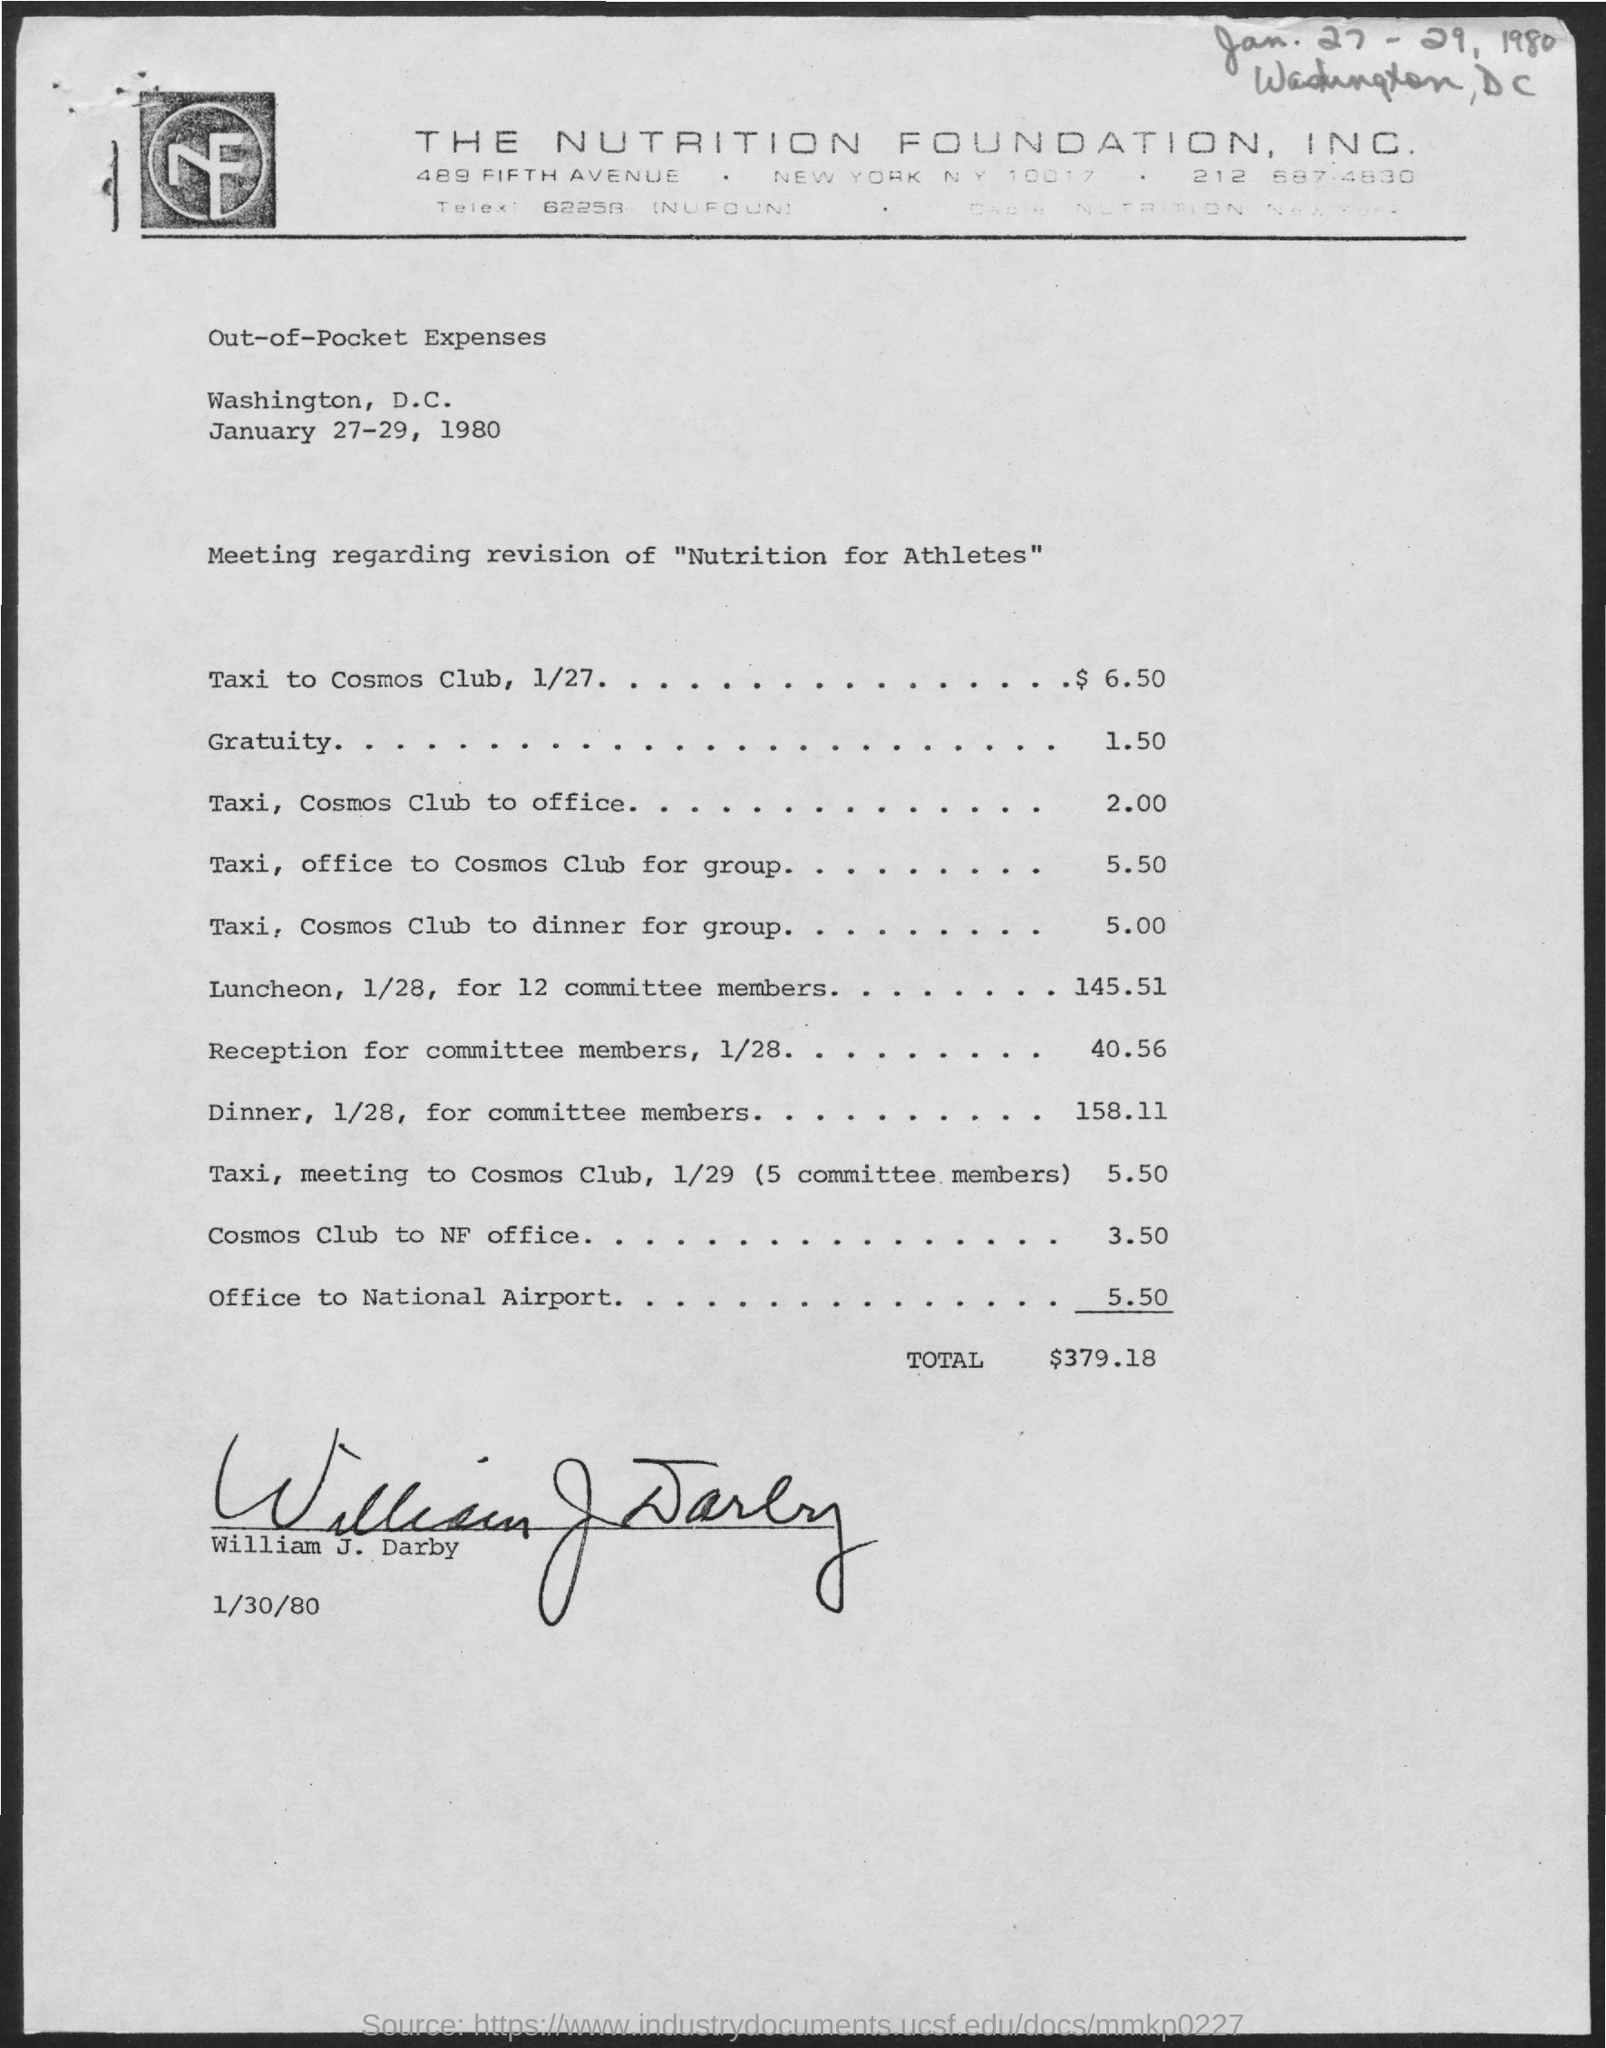Which company is mentioned in the header of the document?
Your answer should be compact. THE NUTRITION FOUNDATION, INC. What is the total out-of-pocket expenses given in the document?
Ensure brevity in your answer.  $379.18. Who has signed this document?
Your answer should be compact. William J. Darby. 